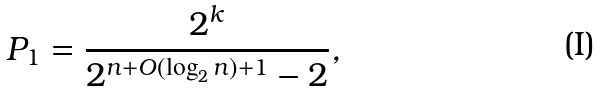<formula> <loc_0><loc_0><loc_500><loc_500>P _ { 1 } = \frac { 2 ^ { k } } { 2 ^ { n + O ( \log _ { 2 } n ) + 1 } - 2 } ,</formula> 